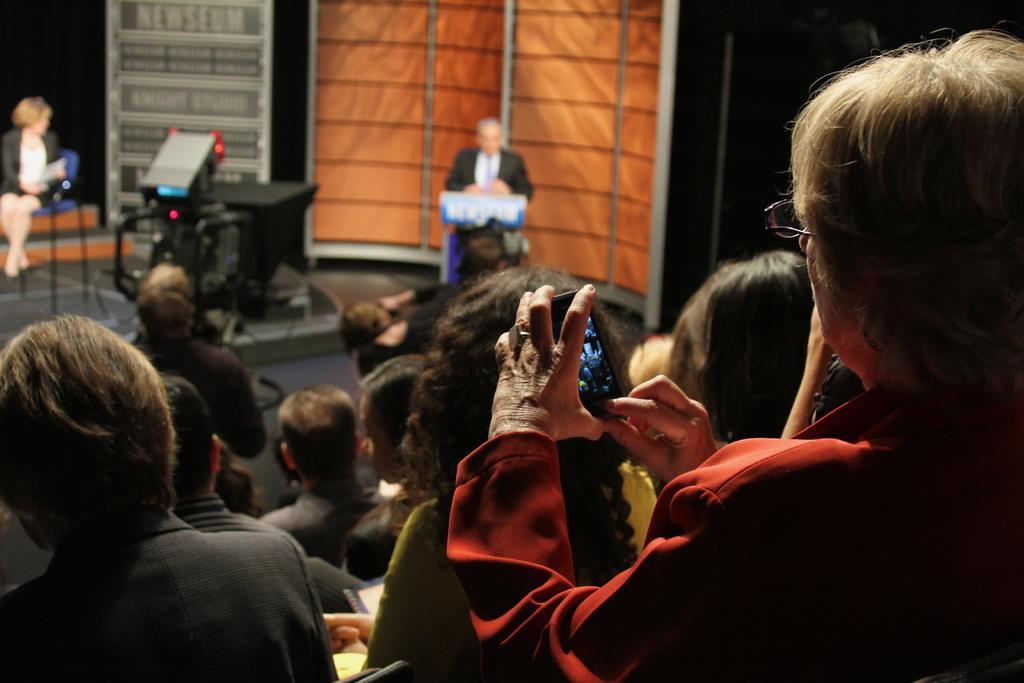Could you give a brief overview of what you see in this image? In this image, we can see persons wearing clothes. There is a person on the right side of the image holding a phone with her hands. There is an another person on the left side of the image sitting on the chair. There is a monitor in the middle of the image. 